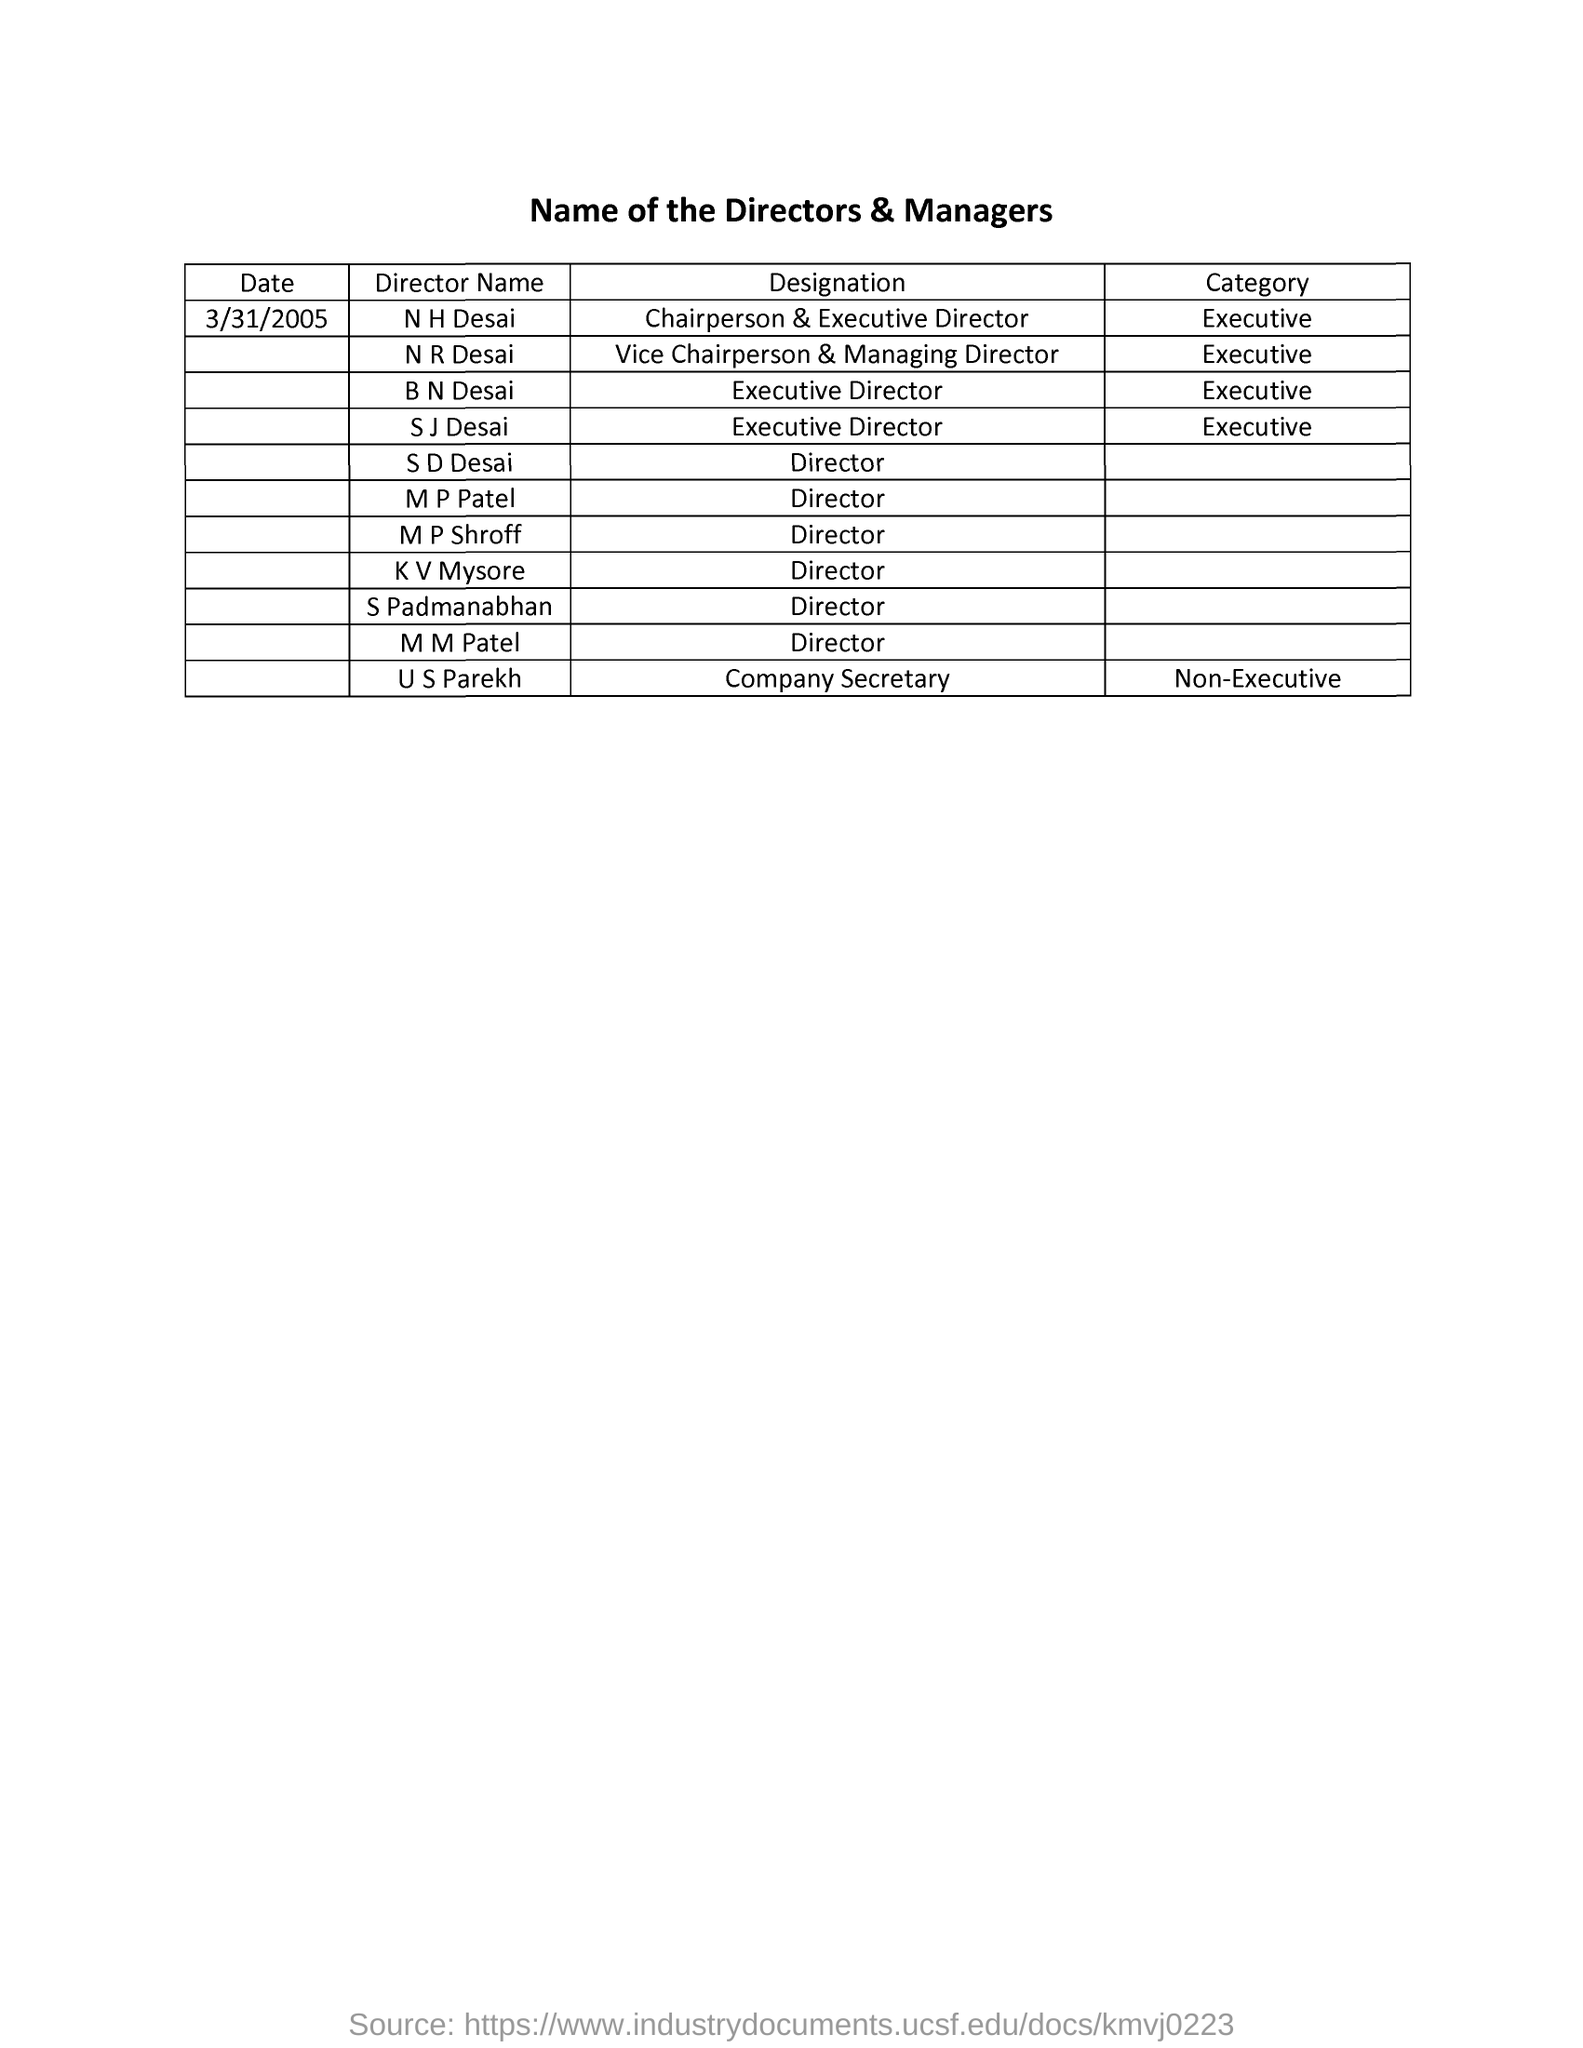what is the category of N R Desai ? N R Desai is categorized as an 'Executive'. This classification typically denotes a higher level of management responsibility and decision-making authority within a company. As the Vice Chairperson & Managing Director, this role is pivotal in strategic planning and corporate leadership. 